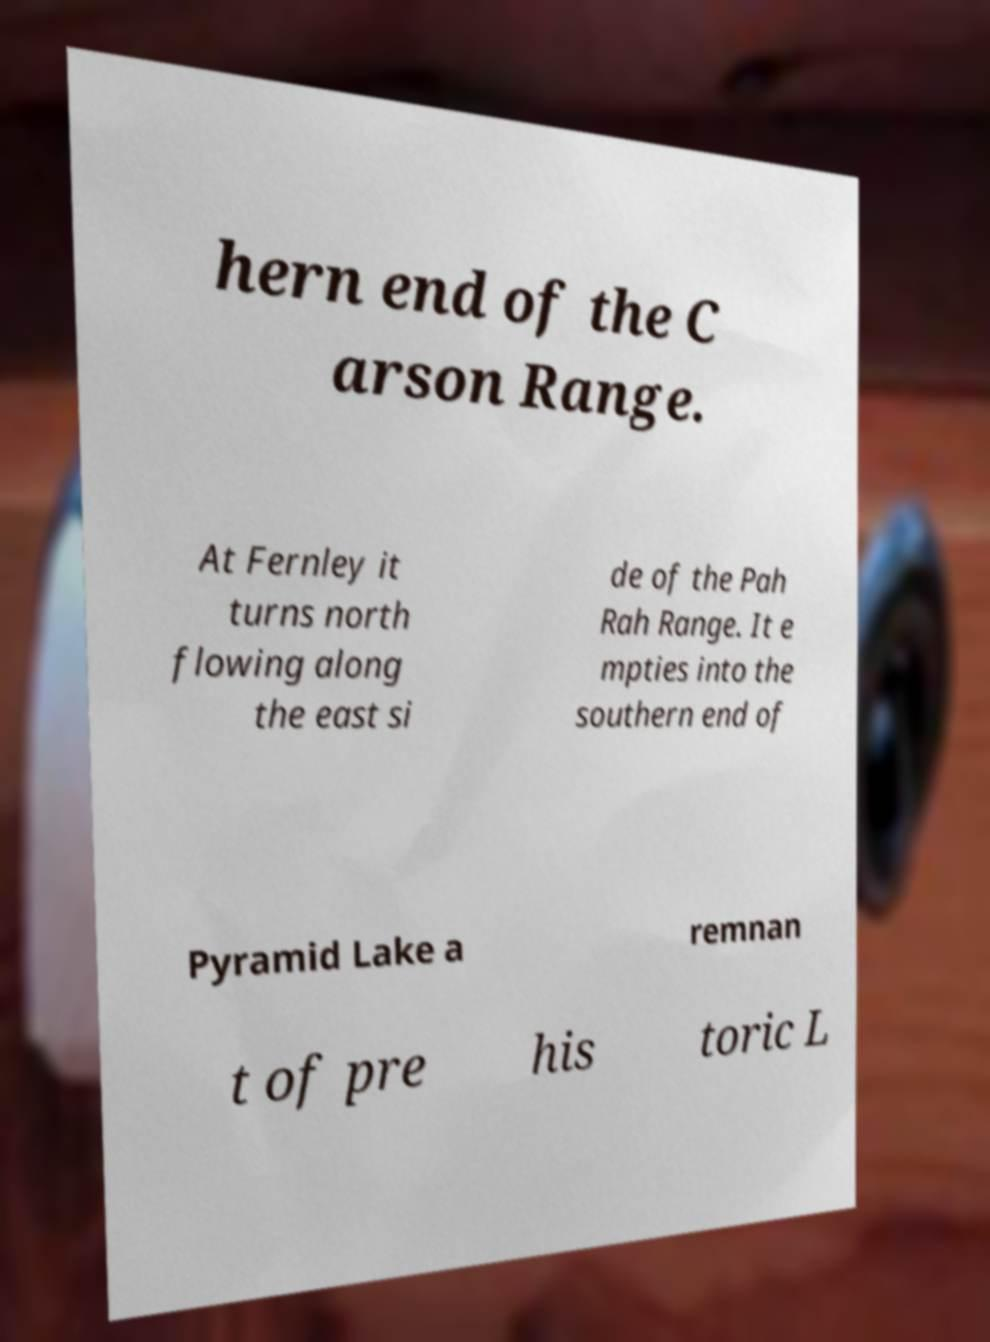Could you extract and type out the text from this image? hern end of the C arson Range. At Fernley it turns north flowing along the east si de of the Pah Rah Range. It e mpties into the southern end of Pyramid Lake a remnan t of pre his toric L 